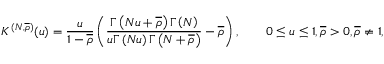<formula> <loc_0><loc_0><loc_500><loc_500>K ^ { ( N , \overline { \rho } ) } ( u ) = \frac { u } { 1 - \overline { \rho } } \left ( \frac { \Gamma \left ( N u + \overline { \rho } \right ) \Gamma \left ( N \right ) } { u \Gamma \left ( N u \right ) \Gamma \left ( N + \overline { \rho } \right ) } - \overline { \rho } \right ) , \quad 0 \leq u \leq 1 , \overline { \rho } > 0 , \overline { \rho } \neq 1 ,</formula> 